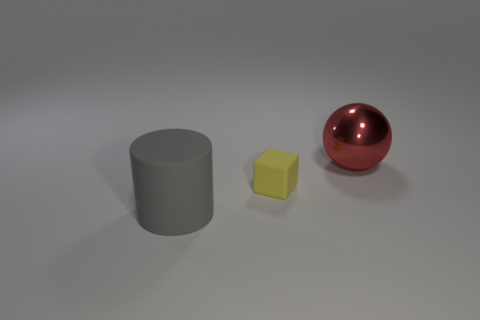Add 3 tiny purple matte things. How many objects exist? 6 Subtract all balls. How many objects are left? 2 Subtract all small yellow rubber balls. Subtract all big red shiny objects. How many objects are left? 2 Add 1 yellow rubber blocks. How many yellow rubber blocks are left? 2 Add 3 large gray rubber cylinders. How many large gray rubber cylinders exist? 4 Subtract 1 gray cylinders. How many objects are left? 2 